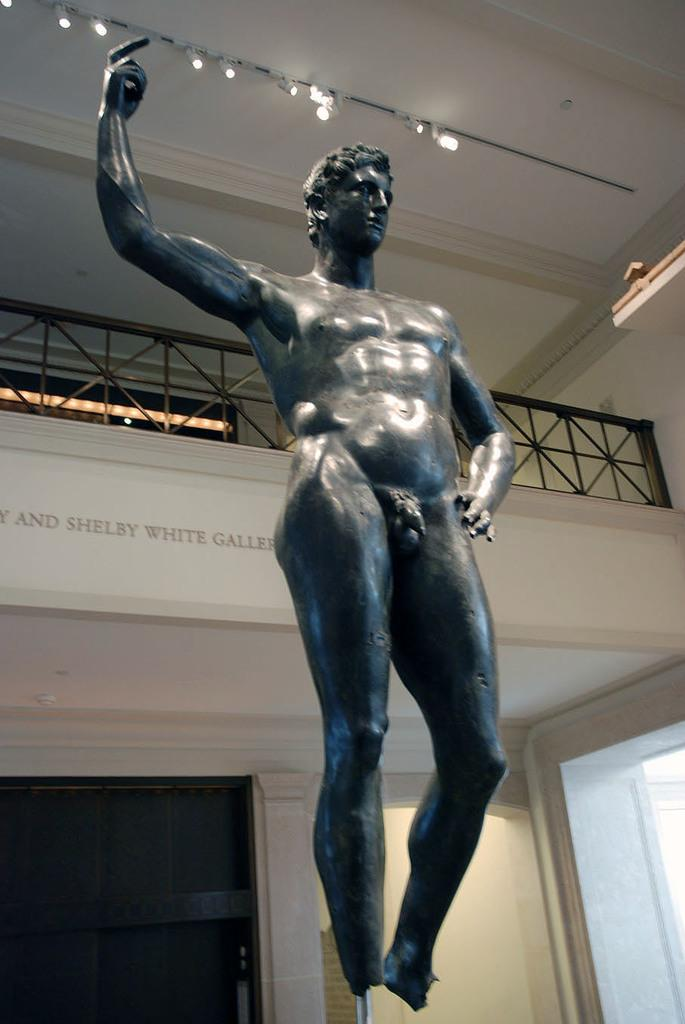What is the main subject of the image? There is a sculpture in the image. Can you describe the setting or background of the sculpture? There is a railing behind the sculpture. Where is the nearest mailbox to the sculpture in the image? There is no mailbox present in the image, so it cannot be determined from the image. 